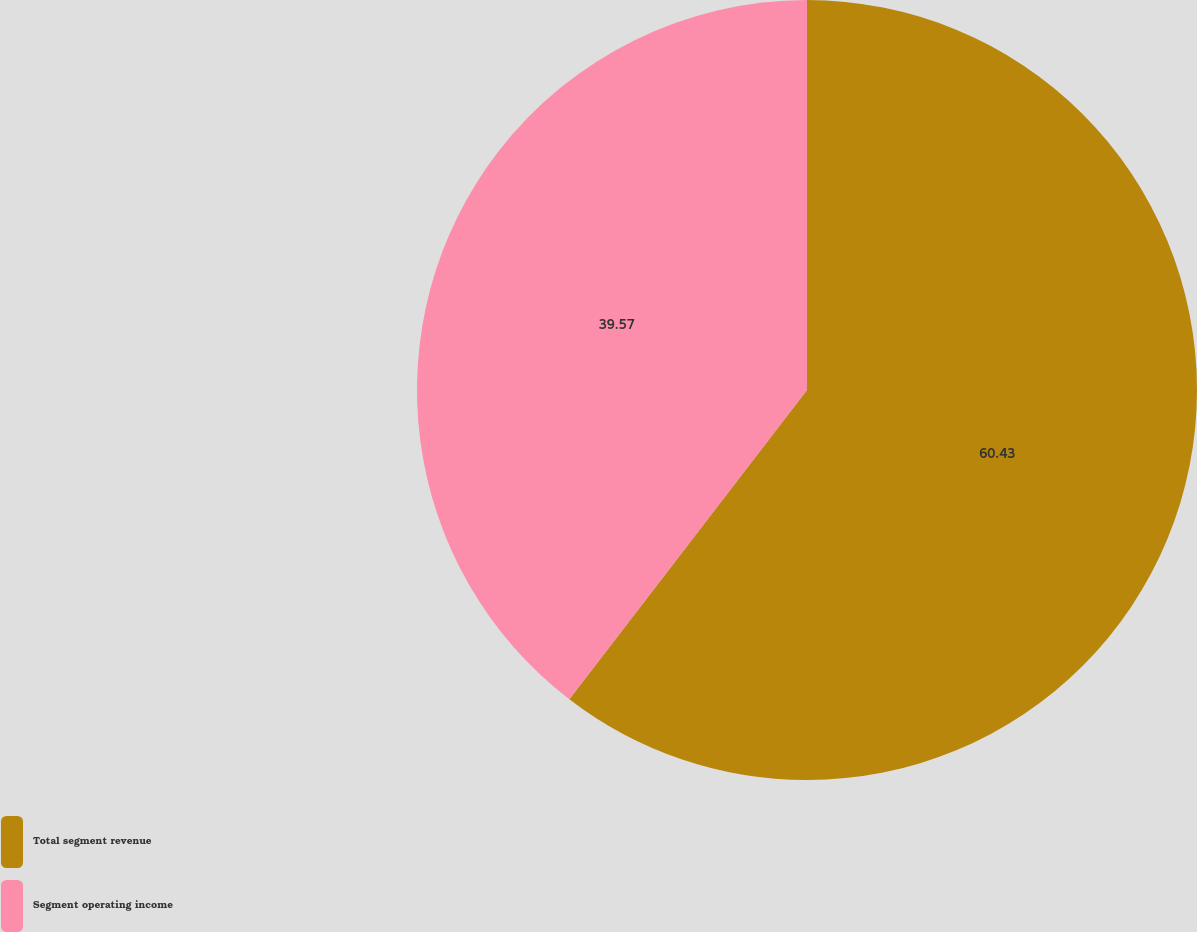Convert chart to OTSL. <chart><loc_0><loc_0><loc_500><loc_500><pie_chart><fcel>Total segment revenue<fcel>Segment operating income<nl><fcel>60.43%<fcel>39.57%<nl></chart> 